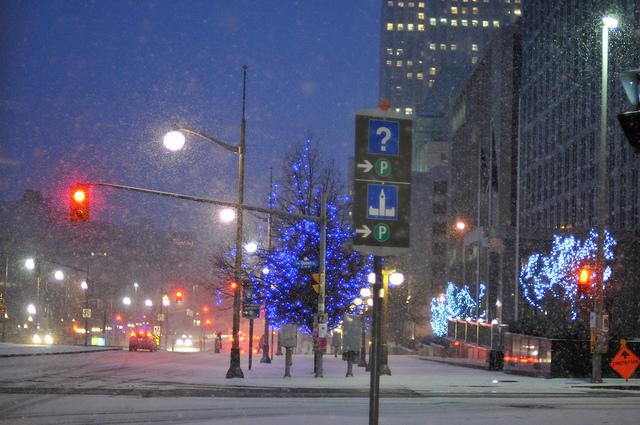Why have they made the trees blue? Please explain your reasoning. holidays. People put up coloured lights during the holidays. 